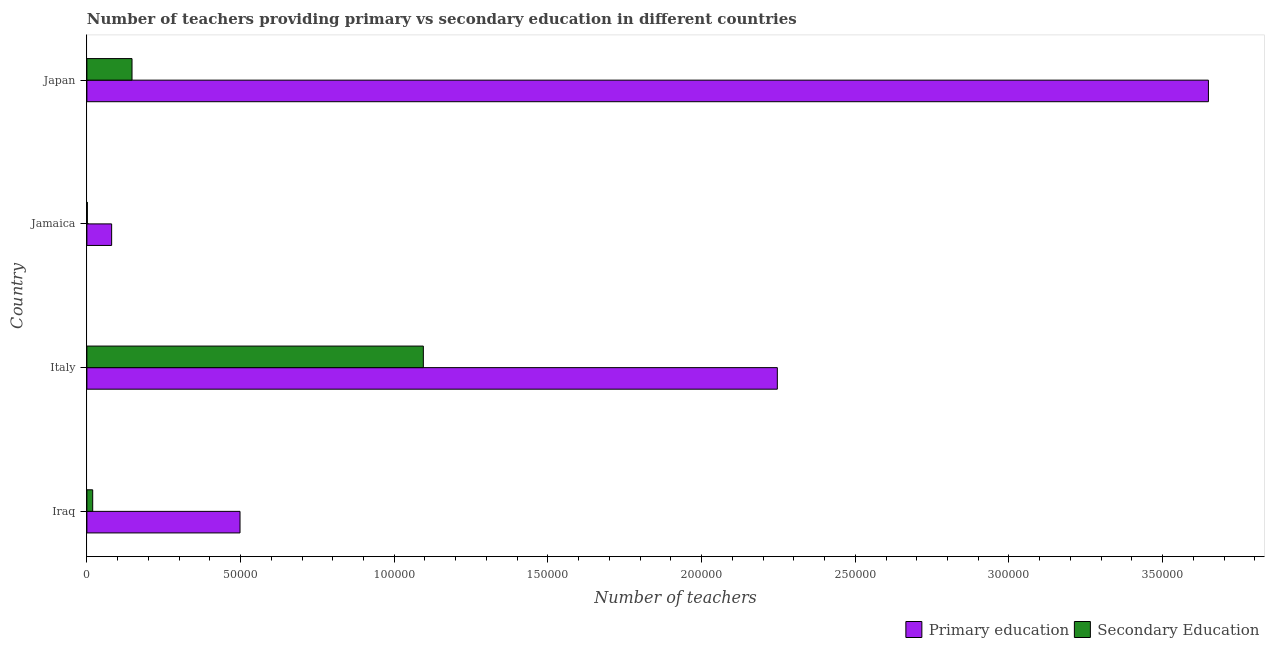Are the number of bars per tick equal to the number of legend labels?
Offer a terse response. Yes. Are the number of bars on each tick of the Y-axis equal?
Your answer should be compact. Yes. What is the number of secondary teachers in Iraq?
Provide a short and direct response. 1890. Across all countries, what is the maximum number of secondary teachers?
Your answer should be very brief. 1.09e+05. Across all countries, what is the minimum number of primary teachers?
Your answer should be very brief. 8053. In which country was the number of secondary teachers minimum?
Make the answer very short. Jamaica. What is the total number of primary teachers in the graph?
Offer a very short reply. 6.47e+05. What is the difference between the number of secondary teachers in Iraq and that in Japan?
Your answer should be very brief. -1.28e+04. What is the difference between the number of primary teachers in Italy and the number of secondary teachers in Iraq?
Give a very brief answer. 2.23e+05. What is the average number of secondary teachers per country?
Your answer should be very brief. 3.15e+04. What is the difference between the number of secondary teachers and number of primary teachers in Jamaica?
Provide a short and direct response. -7909. In how many countries, is the number of primary teachers greater than 280000 ?
Your answer should be very brief. 1. What is the ratio of the number of secondary teachers in Iraq to that in Japan?
Your answer should be compact. 0.13. Is the number of primary teachers in Italy less than that in Jamaica?
Provide a short and direct response. No. Is the difference between the number of secondary teachers in Iraq and Jamaica greater than the difference between the number of primary teachers in Iraq and Jamaica?
Keep it short and to the point. No. What is the difference between the highest and the second highest number of primary teachers?
Offer a terse response. 1.40e+05. What is the difference between the highest and the lowest number of secondary teachers?
Provide a short and direct response. 1.09e+05. In how many countries, is the number of secondary teachers greater than the average number of secondary teachers taken over all countries?
Your answer should be compact. 1. Is the sum of the number of primary teachers in Jamaica and Japan greater than the maximum number of secondary teachers across all countries?
Give a very brief answer. Yes. What does the 2nd bar from the top in Japan represents?
Provide a short and direct response. Primary education. What does the 2nd bar from the bottom in Jamaica represents?
Provide a short and direct response. Secondary Education. How many bars are there?
Provide a short and direct response. 8. Are all the bars in the graph horizontal?
Keep it short and to the point. Yes. Does the graph contain grids?
Provide a short and direct response. No. How many legend labels are there?
Provide a succinct answer. 2. What is the title of the graph?
Give a very brief answer. Number of teachers providing primary vs secondary education in different countries. Does "Female labourers" appear as one of the legend labels in the graph?
Offer a terse response. No. What is the label or title of the X-axis?
Your answer should be very brief. Number of teachers. What is the Number of teachers in Primary education in Iraq?
Offer a terse response. 4.98e+04. What is the Number of teachers in Secondary Education in Iraq?
Keep it short and to the point. 1890. What is the Number of teachers of Primary education in Italy?
Your answer should be very brief. 2.25e+05. What is the Number of teachers in Secondary Education in Italy?
Keep it short and to the point. 1.09e+05. What is the Number of teachers of Primary education in Jamaica?
Your response must be concise. 8053. What is the Number of teachers in Secondary Education in Jamaica?
Your answer should be compact. 144. What is the Number of teachers in Primary education in Japan?
Offer a very short reply. 3.65e+05. What is the Number of teachers in Secondary Education in Japan?
Ensure brevity in your answer.  1.47e+04. Across all countries, what is the maximum Number of teachers of Primary education?
Your answer should be compact. 3.65e+05. Across all countries, what is the maximum Number of teachers in Secondary Education?
Provide a succinct answer. 1.09e+05. Across all countries, what is the minimum Number of teachers in Primary education?
Your response must be concise. 8053. Across all countries, what is the minimum Number of teachers in Secondary Education?
Give a very brief answer. 144. What is the total Number of teachers in Primary education in the graph?
Make the answer very short. 6.47e+05. What is the total Number of teachers in Secondary Education in the graph?
Give a very brief answer. 1.26e+05. What is the difference between the Number of teachers of Primary education in Iraq and that in Italy?
Provide a succinct answer. -1.75e+05. What is the difference between the Number of teachers of Secondary Education in Iraq and that in Italy?
Provide a short and direct response. -1.08e+05. What is the difference between the Number of teachers in Primary education in Iraq and that in Jamaica?
Your answer should be very brief. 4.18e+04. What is the difference between the Number of teachers of Secondary Education in Iraq and that in Jamaica?
Keep it short and to the point. 1746. What is the difference between the Number of teachers of Primary education in Iraq and that in Japan?
Provide a short and direct response. -3.15e+05. What is the difference between the Number of teachers of Secondary Education in Iraq and that in Japan?
Ensure brevity in your answer.  -1.28e+04. What is the difference between the Number of teachers of Primary education in Italy and that in Jamaica?
Your response must be concise. 2.17e+05. What is the difference between the Number of teachers in Secondary Education in Italy and that in Jamaica?
Your answer should be compact. 1.09e+05. What is the difference between the Number of teachers of Primary education in Italy and that in Japan?
Provide a short and direct response. -1.40e+05. What is the difference between the Number of teachers in Secondary Education in Italy and that in Japan?
Your answer should be very brief. 9.48e+04. What is the difference between the Number of teachers in Primary education in Jamaica and that in Japan?
Provide a short and direct response. -3.57e+05. What is the difference between the Number of teachers in Secondary Education in Jamaica and that in Japan?
Offer a very short reply. -1.45e+04. What is the difference between the Number of teachers in Primary education in Iraq and the Number of teachers in Secondary Education in Italy?
Provide a succinct answer. -5.96e+04. What is the difference between the Number of teachers of Primary education in Iraq and the Number of teachers of Secondary Education in Jamaica?
Ensure brevity in your answer.  4.97e+04. What is the difference between the Number of teachers in Primary education in Iraq and the Number of teachers in Secondary Education in Japan?
Ensure brevity in your answer.  3.51e+04. What is the difference between the Number of teachers of Primary education in Italy and the Number of teachers of Secondary Education in Jamaica?
Make the answer very short. 2.25e+05. What is the difference between the Number of teachers of Primary education in Italy and the Number of teachers of Secondary Education in Japan?
Your response must be concise. 2.10e+05. What is the difference between the Number of teachers of Primary education in Jamaica and the Number of teachers of Secondary Education in Japan?
Keep it short and to the point. -6627. What is the average Number of teachers in Primary education per country?
Offer a terse response. 1.62e+05. What is the average Number of teachers of Secondary Education per country?
Give a very brief answer. 3.15e+04. What is the difference between the Number of teachers of Primary education and Number of teachers of Secondary Education in Iraq?
Offer a terse response. 4.79e+04. What is the difference between the Number of teachers in Primary education and Number of teachers in Secondary Education in Italy?
Your response must be concise. 1.15e+05. What is the difference between the Number of teachers in Primary education and Number of teachers in Secondary Education in Jamaica?
Provide a succinct answer. 7909. What is the difference between the Number of teachers in Primary education and Number of teachers in Secondary Education in Japan?
Offer a terse response. 3.50e+05. What is the ratio of the Number of teachers in Primary education in Iraq to that in Italy?
Your response must be concise. 0.22. What is the ratio of the Number of teachers of Secondary Education in Iraq to that in Italy?
Ensure brevity in your answer.  0.02. What is the ratio of the Number of teachers in Primary education in Iraq to that in Jamaica?
Ensure brevity in your answer.  6.19. What is the ratio of the Number of teachers of Secondary Education in Iraq to that in Jamaica?
Provide a short and direct response. 13.12. What is the ratio of the Number of teachers of Primary education in Iraq to that in Japan?
Ensure brevity in your answer.  0.14. What is the ratio of the Number of teachers of Secondary Education in Iraq to that in Japan?
Your answer should be very brief. 0.13. What is the ratio of the Number of teachers of Primary education in Italy to that in Jamaica?
Give a very brief answer. 27.9. What is the ratio of the Number of teachers in Secondary Education in Italy to that in Jamaica?
Your answer should be compact. 760.21. What is the ratio of the Number of teachers in Primary education in Italy to that in Japan?
Your answer should be very brief. 0.62. What is the ratio of the Number of teachers of Secondary Education in Italy to that in Japan?
Your response must be concise. 7.46. What is the ratio of the Number of teachers of Primary education in Jamaica to that in Japan?
Offer a very short reply. 0.02. What is the ratio of the Number of teachers of Secondary Education in Jamaica to that in Japan?
Provide a succinct answer. 0.01. What is the difference between the highest and the second highest Number of teachers in Primary education?
Keep it short and to the point. 1.40e+05. What is the difference between the highest and the second highest Number of teachers of Secondary Education?
Provide a short and direct response. 9.48e+04. What is the difference between the highest and the lowest Number of teachers of Primary education?
Provide a short and direct response. 3.57e+05. What is the difference between the highest and the lowest Number of teachers in Secondary Education?
Make the answer very short. 1.09e+05. 